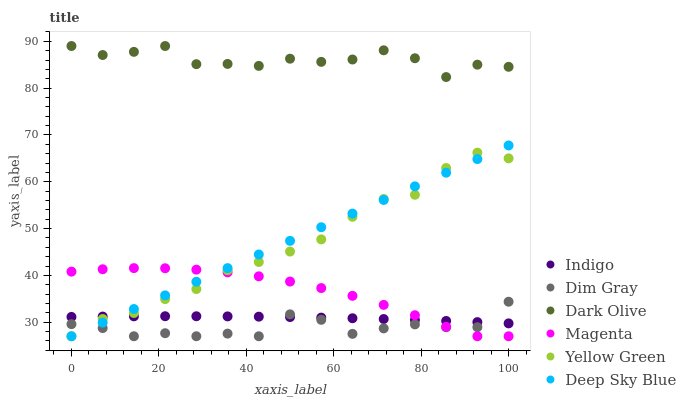Does Dim Gray have the minimum area under the curve?
Answer yes or no. Yes. Does Dark Olive have the maximum area under the curve?
Answer yes or no. Yes. Does Indigo have the minimum area under the curve?
Answer yes or no. No. Does Indigo have the maximum area under the curve?
Answer yes or no. No. Is Deep Sky Blue the smoothest?
Answer yes or no. Yes. Is Dark Olive the roughest?
Answer yes or no. Yes. Is Indigo the smoothest?
Answer yes or no. No. Is Indigo the roughest?
Answer yes or no. No. Does Dim Gray have the lowest value?
Answer yes or no. Yes. Does Indigo have the lowest value?
Answer yes or no. No. Does Dark Olive have the highest value?
Answer yes or no. Yes. Does Yellow Green have the highest value?
Answer yes or no. No. Is Deep Sky Blue less than Dark Olive?
Answer yes or no. Yes. Is Dark Olive greater than Yellow Green?
Answer yes or no. Yes. Does Indigo intersect Magenta?
Answer yes or no. Yes. Is Indigo less than Magenta?
Answer yes or no. No. Is Indigo greater than Magenta?
Answer yes or no. No. Does Deep Sky Blue intersect Dark Olive?
Answer yes or no. No. 